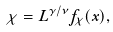<formula> <loc_0><loc_0><loc_500><loc_500>\chi = L ^ { \gamma / \nu } f _ { \chi } ( x ) ,</formula> 